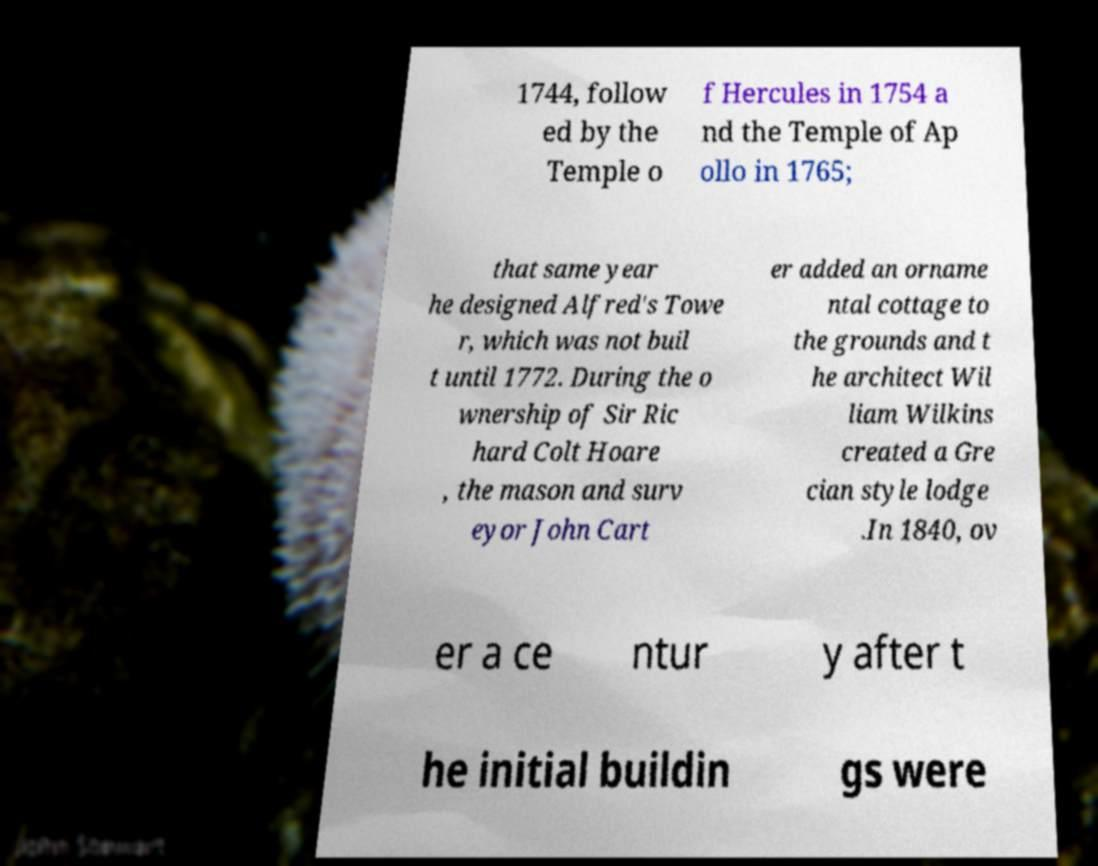Could you assist in decoding the text presented in this image and type it out clearly? 1744, follow ed by the Temple o f Hercules in 1754 a nd the Temple of Ap ollo in 1765; that same year he designed Alfred's Towe r, which was not buil t until 1772. During the o wnership of Sir Ric hard Colt Hoare , the mason and surv eyor John Cart er added an orname ntal cottage to the grounds and t he architect Wil liam Wilkins created a Gre cian style lodge .In 1840, ov er a ce ntur y after t he initial buildin gs were 